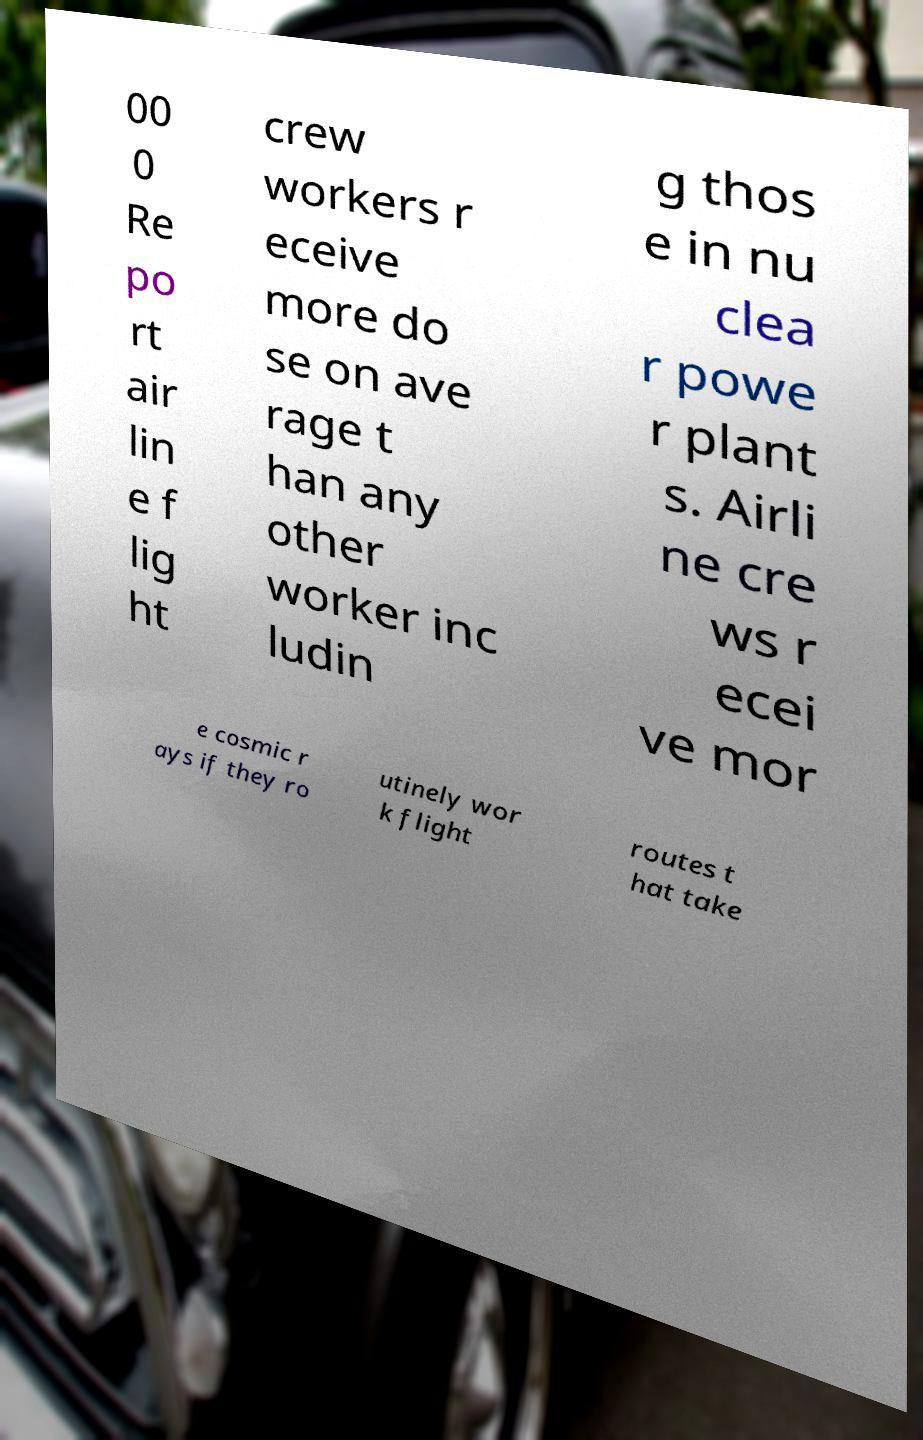Please identify and transcribe the text found in this image. 00 0 Re po rt air lin e f lig ht crew workers r eceive more do se on ave rage t han any other worker inc ludin g thos e in nu clea r powe r plant s. Airli ne cre ws r ecei ve mor e cosmic r ays if they ro utinely wor k flight routes t hat take 